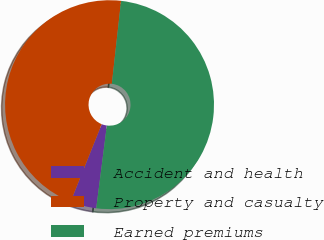<chart> <loc_0><loc_0><loc_500><loc_500><pie_chart><fcel>Accident and health<fcel>Property and casualty<fcel>Earned premiums<nl><fcel>4.04%<fcel>45.69%<fcel>50.26%<nl></chart> 